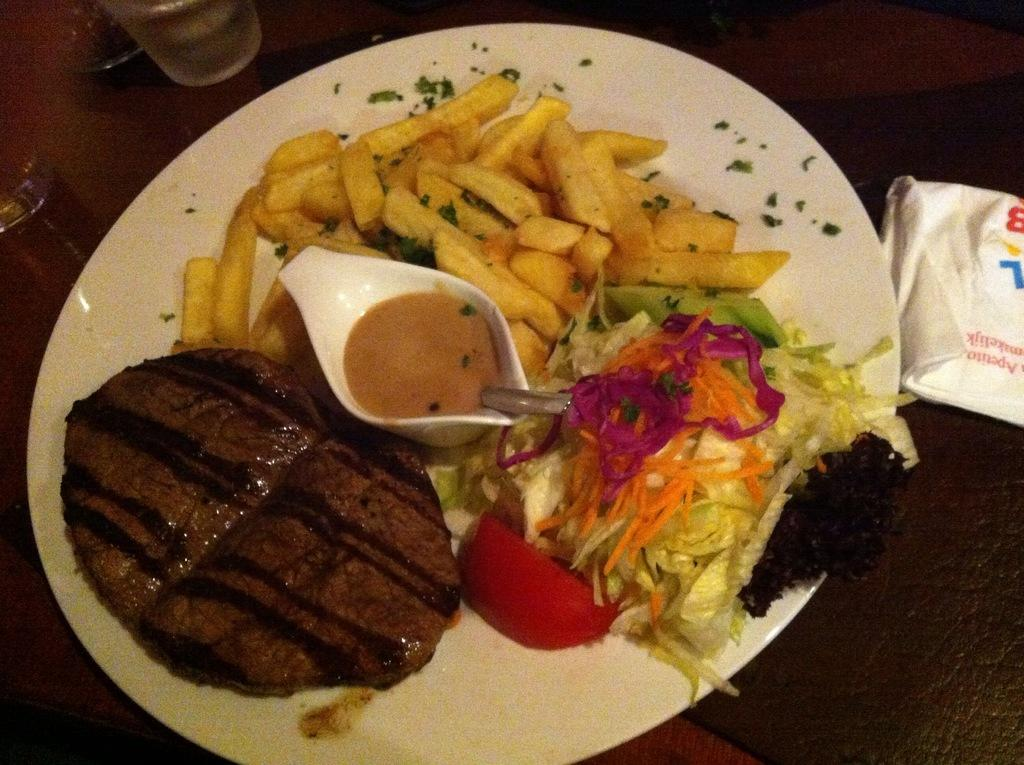What is the main object in the center of the image? There is a table in the center of the image. What can be found on the table? Glasses of drinks and a platter containing food items are on the table. Are there any other items on the table? Yes, there are other items on the table. How many cows are grazing on the table in the image? There are no cows present in the image, and therefore no cows are grazing on the table. What type of sail is attached to the food items on the platter? There is no sail present in the image, as it features a table with glasses of drinks, a platter containing food items, and other items. 